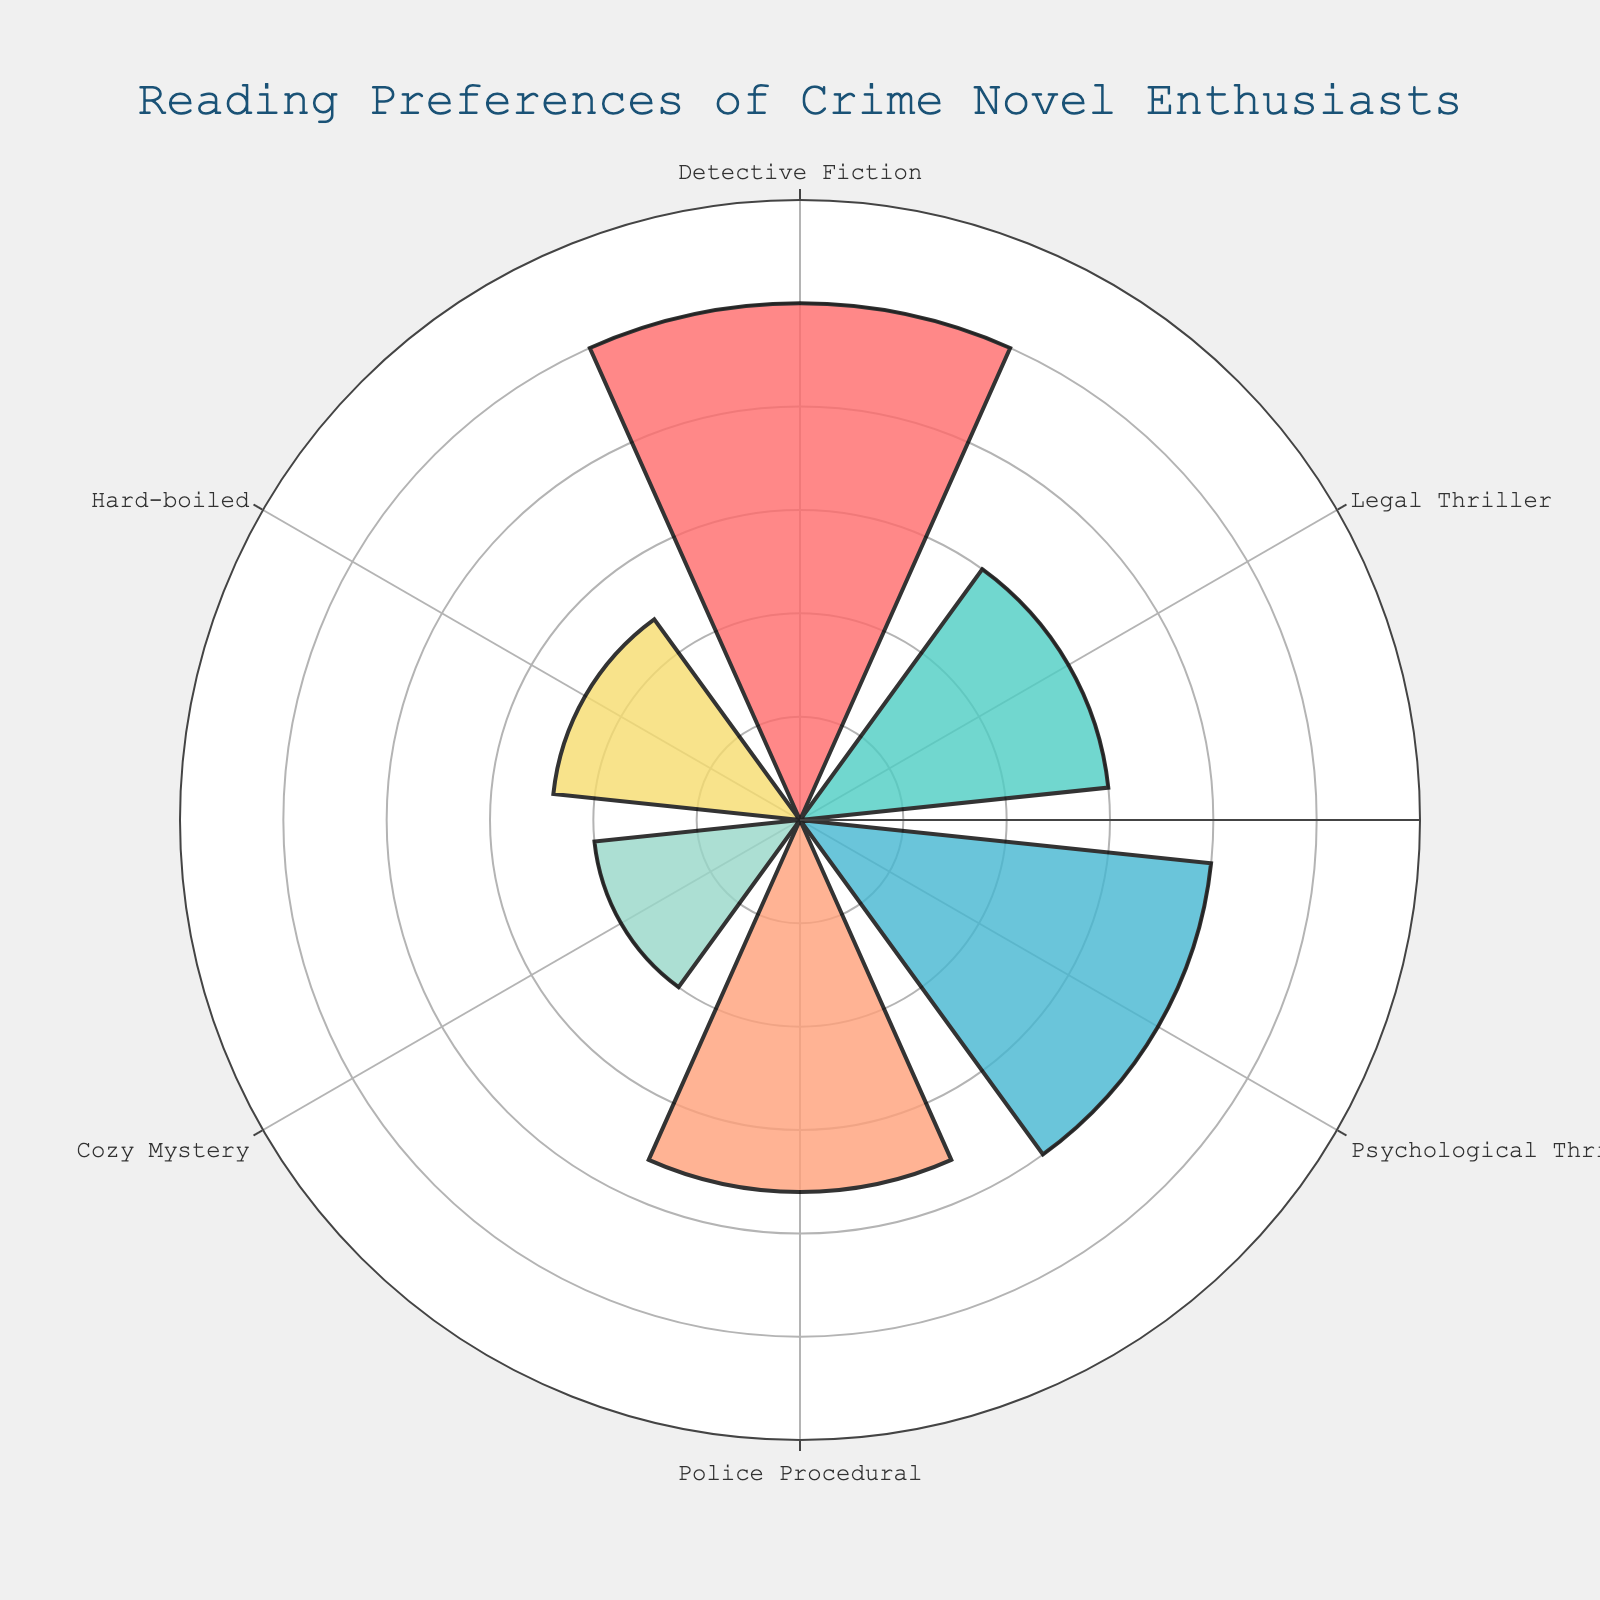What is the title of the chart showing the reading preferences? The title is located at the top of the chart and it reads "Reading Preferences of Crime Novel Enthusiasts".
Answer: Reading Preferences of Crime Novel Enthusiasts Which sub-genre has the highest percentage of readers? The length of the bar representing the percentage is the longest for "Detective Fiction", indicating it has the highest percentage.
Answer: Detective Fiction What are the percentages for Police Procedural and Cozy Mystery combined? Identify the percentage for both "Police Procedural" (18%) and "Cozy Mystery" (10%) and then add them together (18 + 10).
Answer: 28% How many sub-genres are represented in the chart? By counting the distinct labels on the polar chart, we see there are six sub-genres represented.
Answer: Six Which sub-genre has a higher percentage of readers, Hard-boiled or Legal Thriller? Compare the lengths of the bars for "Hard-boiled" (12%) and "Legal Thriller" (15%).
Answer: Legal Thriller What is the difference in percentage between Detective Fiction and Psychological Thriller? Detective Fiction has 25% and Psychological Thriller has 20%. Subtracting these gives 25% - 20%.
Answer: 5% Which sub-genre is represented by a bar with a width of 0.8 and is colored salmon pink? "Detective Fiction" is represented by the longest bar colored salmon pink with a width of 0.8.
Answer: Detective Fiction Is the percentage of readers for Psychological Thriller greater than the combined percentage of Cozy Mystery and Hard-boiled? Cozy Mystery has 10% and Hard-boiled has 12%, combined they equal 22%. Psychological Thriller has 20%, which is less than 22%.
Answer: No Which sub-genre has the smallest percentage of readers? "Cozy Mystery" has the shortest bar, indicating the smallest percentage of 10%.
Answer: Cozy Mystery If the sub-genres were to be rearranged in descending order of reader preference, which sub-genre would be third? Arranging the percentages in descending order, Detective Fiction (25%), Psychological Thriller (20%), and next is Police Procedural at 18%.
Answer: Police Procedural 